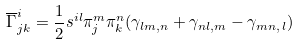Convert formula to latex. <formula><loc_0><loc_0><loc_500><loc_500>\overline { \Gamma } ^ { i } _ { j k } = \frac { 1 } { 2 } s ^ { i l } \pi ^ { m } _ { j } \pi ^ { n } _ { k } ( \gamma _ { l m , n } + \gamma _ { n l , m } - \gamma _ { m n , \, l } )</formula> 